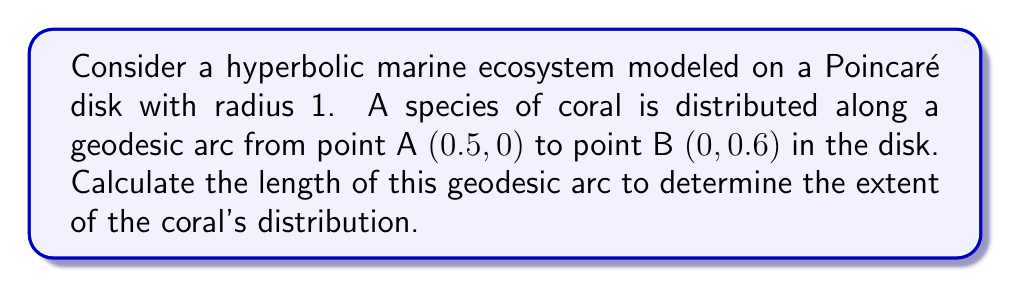Can you answer this question? To solve this problem, we'll follow these steps:

1) In the Poincaré disk model, geodesics are represented by circular arcs perpendicular to the boundary of the disk. We need to find the center and radius of this arc.

2) The general equation of a circle in the complex plane is:
   $$|z - c| = r$$
   where $c$ is the center and $r$ is the radius.

3) For a geodesic perpendicular to the unit circle and passing through points $z_1$ and $z_2$, the center $c$ is given by:
   $$c = \frac{z_1\bar{z_2} - z_2\bar{z_1}}{z_1\bar{z_2} - \bar{z_1}z_2}$$

4) Let $z_1 = 0.5$ and $z_2 = 0.6i$. Substituting:
   $$c = \frac{0.5(0.6i) - 0.6i(0.5)}{0.5(0.6i) - (-0.6i)(0.5)} = \frac{0.3i - 0.3i}{0.3i + 0.3i} = 0.5$$

5) The radius $r$ can be found using:
   $$r^2 = |c|^2 - 1 = 0.5^2 - 1 = -0.75$$
   $$r = \sqrt{0.75} = \frac{\sqrt{3}}{2}$$

6) The hyperbolic distance $d$ between two points $z_1$ and $z_2$ on a geodesic arc is given by:
   $$d = 2\tanh^{-1}\left|\frac{z_1 - z_2}{1 - \bar{z_1}z_2}\right|$$

7) Substituting our values:
   $$d = 2\tanh^{-1}\left|\frac{0.5 - 0.6i}{1 - 0.5(0.6i)}\right| = 2\tanh^{-1}\left|\frac{0.5 - 0.6i}{1 - 0.3i}\right|$$

8) Simplifying the complex fraction:
   $$d = 2\tanh^{-1}\left|\frac{(0.5 - 0.6i)(1 + 0.3i)}{(1 - 0.3i)(1 + 0.3i)}\right| = 2\tanh^{-1}\left|\frac{0.68 - 0.42i}{1.09}\right|$$

9) Calculating the magnitude:
   $$d = 2\tanh^{-1}\left(\frac{\sqrt{0.68^2 + 0.42^2}}{1.09}\right) = 2\tanh^{-1}(0.7303)$$

10) Finally:
    $$d = 2 * 0.9292 = 1.8584$$

Therefore, the length of the geodesic arc representing the coral's distribution is approximately 1.8584 in hyperbolic units.
Answer: 1.8584 hyperbolic units 